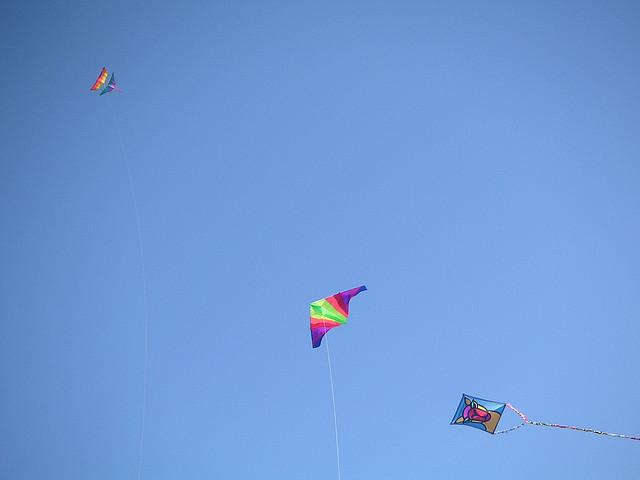What is on the kite?
Answer briefly. String. What is the main color of the kite in front?
Be succinct. Green. How many kites are stringed together?
Write a very short answer. 0. How many items are in the photo?
Short answer required. 3. Is there any kind of building visible?
Be succinct. No. Is this picture taken looking up or down?
Answer briefly. Up. What shape is the lower kite?
Short answer required. Square. Are the kites high in the sky?
Keep it brief. Yes. What is your favorite kite?
Short answer required. Middle. 